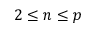Convert formula to latex. <formula><loc_0><loc_0><loc_500><loc_500>2 \leq n \leq p</formula> 